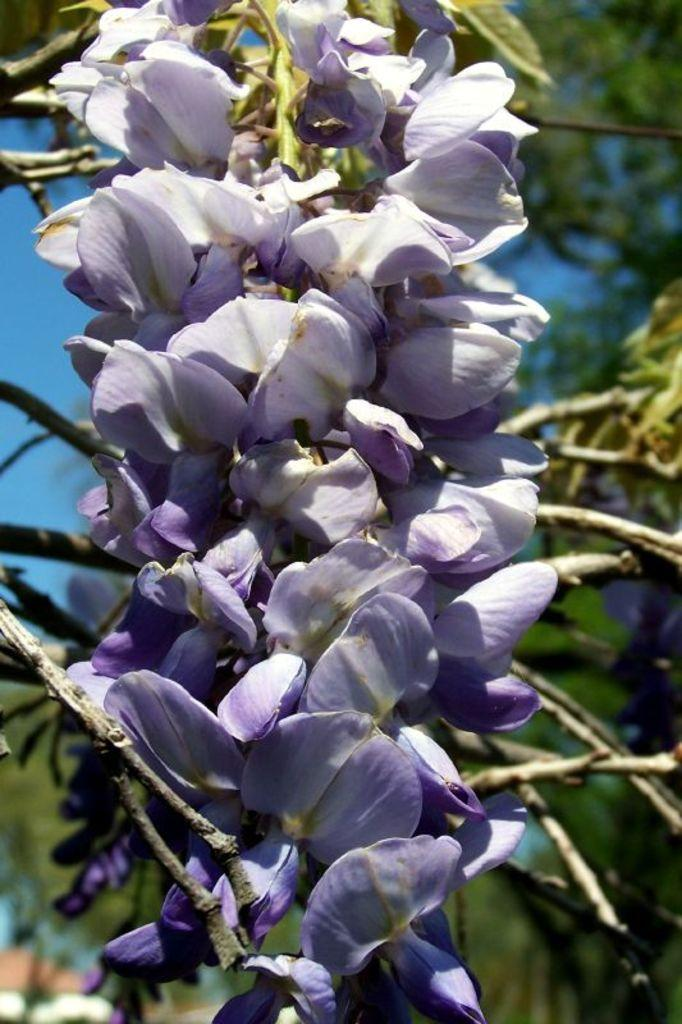What type of vegetation is in the front of the image? There are flowers in the front of the image. What type of vegetation is in the background of the image? There are trees in the background of the image. What type of representative can be seen in the image? There is no representative present in the image; it features flowers in the front and trees in the background. How do the cows feel about the flowers in the image? There are no cows present in the image, so it is not possible to determine their feelings about the flowers. 